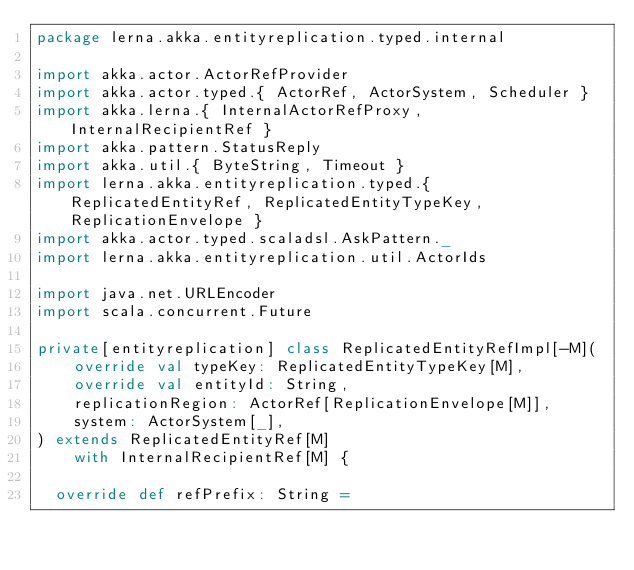<code> <loc_0><loc_0><loc_500><loc_500><_Scala_>package lerna.akka.entityreplication.typed.internal

import akka.actor.ActorRefProvider
import akka.actor.typed.{ ActorRef, ActorSystem, Scheduler }
import akka.lerna.{ InternalActorRefProxy, InternalRecipientRef }
import akka.pattern.StatusReply
import akka.util.{ ByteString, Timeout }
import lerna.akka.entityreplication.typed.{ ReplicatedEntityRef, ReplicatedEntityTypeKey, ReplicationEnvelope }
import akka.actor.typed.scaladsl.AskPattern._
import lerna.akka.entityreplication.util.ActorIds

import java.net.URLEncoder
import scala.concurrent.Future

private[entityreplication] class ReplicatedEntityRefImpl[-M](
    override val typeKey: ReplicatedEntityTypeKey[M],
    override val entityId: String,
    replicationRegion: ActorRef[ReplicationEnvelope[M]],
    system: ActorSystem[_],
) extends ReplicatedEntityRef[M]
    with InternalRecipientRef[M] {

  override def refPrefix: String =</code> 